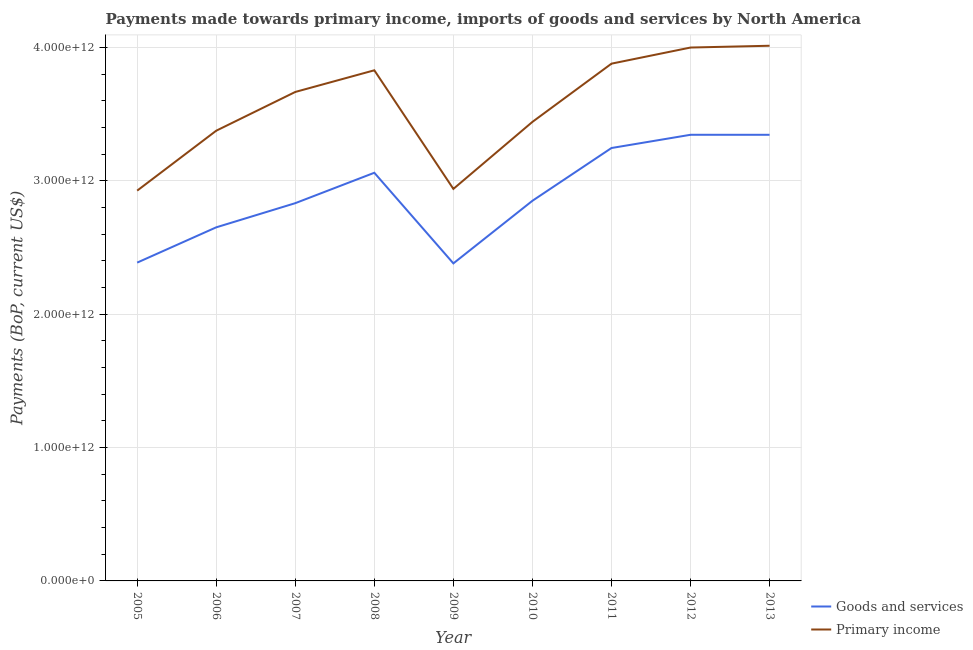Does the line corresponding to payments made towards goods and services intersect with the line corresponding to payments made towards primary income?
Your answer should be compact. No. What is the payments made towards primary income in 2012?
Provide a short and direct response. 4.00e+12. Across all years, what is the maximum payments made towards primary income?
Offer a terse response. 4.01e+12. Across all years, what is the minimum payments made towards goods and services?
Offer a very short reply. 2.38e+12. In which year was the payments made towards primary income minimum?
Your answer should be very brief. 2005. What is the total payments made towards goods and services in the graph?
Offer a terse response. 2.61e+13. What is the difference between the payments made towards goods and services in 2005 and that in 2012?
Make the answer very short. -9.58e+11. What is the difference between the payments made towards goods and services in 2006 and the payments made towards primary income in 2008?
Offer a terse response. -1.18e+12. What is the average payments made towards goods and services per year?
Offer a very short reply. 2.90e+12. In the year 2011, what is the difference between the payments made towards primary income and payments made towards goods and services?
Your answer should be very brief. 6.32e+11. What is the ratio of the payments made towards primary income in 2010 to that in 2012?
Provide a short and direct response. 0.86. Is the payments made towards primary income in 2006 less than that in 2008?
Offer a terse response. Yes. Is the difference between the payments made towards goods and services in 2008 and 2010 greater than the difference between the payments made towards primary income in 2008 and 2010?
Keep it short and to the point. No. What is the difference between the highest and the second highest payments made towards goods and services?
Give a very brief answer. 1.09e+08. What is the difference between the highest and the lowest payments made towards goods and services?
Give a very brief answer. 9.64e+11. Is the payments made towards primary income strictly greater than the payments made towards goods and services over the years?
Keep it short and to the point. Yes. What is the difference between two consecutive major ticks on the Y-axis?
Make the answer very short. 1.00e+12. Are the values on the major ticks of Y-axis written in scientific E-notation?
Ensure brevity in your answer.  Yes. Does the graph contain any zero values?
Give a very brief answer. No. How many legend labels are there?
Give a very brief answer. 2. How are the legend labels stacked?
Provide a succinct answer. Vertical. What is the title of the graph?
Your answer should be very brief. Payments made towards primary income, imports of goods and services by North America. What is the label or title of the Y-axis?
Your response must be concise. Payments (BoP, current US$). What is the Payments (BoP, current US$) of Goods and services in 2005?
Your answer should be very brief. 2.39e+12. What is the Payments (BoP, current US$) in Primary income in 2005?
Your response must be concise. 2.93e+12. What is the Payments (BoP, current US$) of Goods and services in 2006?
Make the answer very short. 2.65e+12. What is the Payments (BoP, current US$) in Primary income in 2006?
Ensure brevity in your answer.  3.38e+12. What is the Payments (BoP, current US$) of Goods and services in 2007?
Provide a short and direct response. 2.83e+12. What is the Payments (BoP, current US$) of Primary income in 2007?
Your response must be concise. 3.67e+12. What is the Payments (BoP, current US$) in Goods and services in 2008?
Provide a short and direct response. 3.06e+12. What is the Payments (BoP, current US$) of Primary income in 2008?
Make the answer very short. 3.83e+12. What is the Payments (BoP, current US$) in Goods and services in 2009?
Make the answer very short. 2.38e+12. What is the Payments (BoP, current US$) of Primary income in 2009?
Offer a terse response. 2.94e+12. What is the Payments (BoP, current US$) of Goods and services in 2010?
Your answer should be very brief. 2.85e+12. What is the Payments (BoP, current US$) in Primary income in 2010?
Your response must be concise. 3.44e+12. What is the Payments (BoP, current US$) in Goods and services in 2011?
Ensure brevity in your answer.  3.25e+12. What is the Payments (BoP, current US$) in Primary income in 2011?
Offer a terse response. 3.88e+12. What is the Payments (BoP, current US$) in Goods and services in 2012?
Keep it short and to the point. 3.34e+12. What is the Payments (BoP, current US$) in Primary income in 2012?
Provide a short and direct response. 4.00e+12. What is the Payments (BoP, current US$) in Goods and services in 2013?
Keep it short and to the point. 3.34e+12. What is the Payments (BoP, current US$) of Primary income in 2013?
Provide a short and direct response. 4.01e+12. Across all years, what is the maximum Payments (BoP, current US$) in Goods and services?
Provide a short and direct response. 3.34e+12. Across all years, what is the maximum Payments (BoP, current US$) of Primary income?
Provide a short and direct response. 4.01e+12. Across all years, what is the minimum Payments (BoP, current US$) of Goods and services?
Provide a short and direct response. 2.38e+12. Across all years, what is the minimum Payments (BoP, current US$) in Primary income?
Provide a short and direct response. 2.93e+12. What is the total Payments (BoP, current US$) of Goods and services in the graph?
Your answer should be very brief. 2.61e+13. What is the total Payments (BoP, current US$) of Primary income in the graph?
Make the answer very short. 3.21e+13. What is the difference between the Payments (BoP, current US$) of Goods and services in 2005 and that in 2006?
Give a very brief answer. -2.65e+11. What is the difference between the Payments (BoP, current US$) in Primary income in 2005 and that in 2006?
Make the answer very short. -4.49e+11. What is the difference between the Payments (BoP, current US$) of Goods and services in 2005 and that in 2007?
Your response must be concise. -4.46e+11. What is the difference between the Payments (BoP, current US$) of Primary income in 2005 and that in 2007?
Your answer should be very brief. -7.40e+11. What is the difference between the Payments (BoP, current US$) of Goods and services in 2005 and that in 2008?
Provide a succinct answer. -6.74e+11. What is the difference between the Payments (BoP, current US$) of Primary income in 2005 and that in 2008?
Offer a terse response. -9.02e+11. What is the difference between the Payments (BoP, current US$) of Goods and services in 2005 and that in 2009?
Keep it short and to the point. 5.74e+09. What is the difference between the Payments (BoP, current US$) of Primary income in 2005 and that in 2009?
Your answer should be very brief. -1.30e+1. What is the difference between the Payments (BoP, current US$) in Goods and services in 2005 and that in 2010?
Your answer should be very brief. -4.64e+11. What is the difference between the Payments (BoP, current US$) of Primary income in 2005 and that in 2010?
Offer a terse response. -5.15e+11. What is the difference between the Payments (BoP, current US$) of Goods and services in 2005 and that in 2011?
Provide a succinct answer. -8.59e+11. What is the difference between the Payments (BoP, current US$) in Primary income in 2005 and that in 2011?
Provide a succinct answer. -9.52e+11. What is the difference between the Payments (BoP, current US$) in Goods and services in 2005 and that in 2012?
Provide a succinct answer. -9.58e+11. What is the difference between the Payments (BoP, current US$) in Primary income in 2005 and that in 2012?
Make the answer very short. -1.07e+12. What is the difference between the Payments (BoP, current US$) of Goods and services in 2005 and that in 2013?
Ensure brevity in your answer.  -9.58e+11. What is the difference between the Payments (BoP, current US$) in Primary income in 2005 and that in 2013?
Ensure brevity in your answer.  -1.09e+12. What is the difference between the Payments (BoP, current US$) in Goods and services in 2006 and that in 2007?
Your response must be concise. -1.81e+11. What is the difference between the Payments (BoP, current US$) in Primary income in 2006 and that in 2007?
Ensure brevity in your answer.  -2.91e+11. What is the difference between the Payments (BoP, current US$) in Goods and services in 2006 and that in 2008?
Your answer should be compact. -4.09e+11. What is the difference between the Payments (BoP, current US$) in Primary income in 2006 and that in 2008?
Offer a terse response. -4.53e+11. What is the difference between the Payments (BoP, current US$) of Goods and services in 2006 and that in 2009?
Make the answer very short. 2.70e+11. What is the difference between the Payments (BoP, current US$) in Primary income in 2006 and that in 2009?
Keep it short and to the point. 4.36e+11. What is the difference between the Payments (BoP, current US$) of Goods and services in 2006 and that in 2010?
Keep it short and to the point. -1.99e+11. What is the difference between the Payments (BoP, current US$) in Primary income in 2006 and that in 2010?
Your response must be concise. -6.61e+1. What is the difference between the Payments (BoP, current US$) of Goods and services in 2006 and that in 2011?
Ensure brevity in your answer.  -5.95e+11. What is the difference between the Payments (BoP, current US$) of Primary income in 2006 and that in 2011?
Make the answer very short. -5.03e+11. What is the difference between the Payments (BoP, current US$) in Goods and services in 2006 and that in 2012?
Your response must be concise. -6.94e+11. What is the difference between the Payments (BoP, current US$) in Primary income in 2006 and that in 2012?
Ensure brevity in your answer.  -6.24e+11. What is the difference between the Payments (BoP, current US$) in Goods and services in 2006 and that in 2013?
Your answer should be compact. -6.94e+11. What is the difference between the Payments (BoP, current US$) of Primary income in 2006 and that in 2013?
Your answer should be compact. -6.37e+11. What is the difference between the Payments (BoP, current US$) in Goods and services in 2007 and that in 2008?
Give a very brief answer. -2.28e+11. What is the difference between the Payments (BoP, current US$) of Primary income in 2007 and that in 2008?
Provide a short and direct response. -1.62e+11. What is the difference between the Payments (BoP, current US$) of Goods and services in 2007 and that in 2009?
Your response must be concise. 4.51e+11. What is the difference between the Payments (BoP, current US$) in Primary income in 2007 and that in 2009?
Provide a short and direct response. 7.27e+11. What is the difference between the Payments (BoP, current US$) in Goods and services in 2007 and that in 2010?
Provide a short and direct response. -1.79e+1. What is the difference between the Payments (BoP, current US$) in Primary income in 2007 and that in 2010?
Offer a very short reply. 2.24e+11. What is the difference between the Payments (BoP, current US$) of Goods and services in 2007 and that in 2011?
Ensure brevity in your answer.  -4.14e+11. What is the difference between the Payments (BoP, current US$) of Primary income in 2007 and that in 2011?
Provide a succinct answer. -2.12e+11. What is the difference between the Payments (BoP, current US$) of Goods and services in 2007 and that in 2012?
Give a very brief answer. -5.13e+11. What is the difference between the Payments (BoP, current US$) in Primary income in 2007 and that in 2012?
Make the answer very short. -3.33e+11. What is the difference between the Payments (BoP, current US$) in Goods and services in 2007 and that in 2013?
Give a very brief answer. -5.13e+11. What is the difference between the Payments (BoP, current US$) in Primary income in 2007 and that in 2013?
Your response must be concise. -3.46e+11. What is the difference between the Payments (BoP, current US$) of Goods and services in 2008 and that in 2009?
Offer a very short reply. 6.79e+11. What is the difference between the Payments (BoP, current US$) of Primary income in 2008 and that in 2009?
Offer a very short reply. 8.89e+11. What is the difference between the Payments (BoP, current US$) of Goods and services in 2008 and that in 2010?
Your answer should be very brief. 2.10e+11. What is the difference between the Payments (BoP, current US$) of Primary income in 2008 and that in 2010?
Make the answer very short. 3.87e+11. What is the difference between the Payments (BoP, current US$) in Goods and services in 2008 and that in 2011?
Provide a short and direct response. -1.86e+11. What is the difference between the Payments (BoP, current US$) of Primary income in 2008 and that in 2011?
Give a very brief answer. -4.97e+1. What is the difference between the Payments (BoP, current US$) of Goods and services in 2008 and that in 2012?
Your response must be concise. -2.85e+11. What is the difference between the Payments (BoP, current US$) in Primary income in 2008 and that in 2012?
Your answer should be very brief. -1.71e+11. What is the difference between the Payments (BoP, current US$) of Goods and services in 2008 and that in 2013?
Your answer should be compact. -2.85e+11. What is the difference between the Payments (BoP, current US$) in Primary income in 2008 and that in 2013?
Your response must be concise. -1.84e+11. What is the difference between the Payments (BoP, current US$) in Goods and services in 2009 and that in 2010?
Keep it short and to the point. -4.69e+11. What is the difference between the Payments (BoP, current US$) of Primary income in 2009 and that in 2010?
Your response must be concise. -5.02e+11. What is the difference between the Payments (BoP, current US$) in Goods and services in 2009 and that in 2011?
Your answer should be compact. -8.65e+11. What is the difference between the Payments (BoP, current US$) in Primary income in 2009 and that in 2011?
Provide a succinct answer. -9.39e+11. What is the difference between the Payments (BoP, current US$) in Goods and services in 2009 and that in 2012?
Your answer should be very brief. -9.64e+11. What is the difference between the Payments (BoP, current US$) of Primary income in 2009 and that in 2012?
Provide a short and direct response. -1.06e+12. What is the difference between the Payments (BoP, current US$) of Goods and services in 2009 and that in 2013?
Ensure brevity in your answer.  -9.64e+11. What is the difference between the Payments (BoP, current US$) of Primary income in 2009 and that in 2013?
Your answer should be compact. -1.07e+12. What is the difference between the Payments (BoP, current US$) in Goods and services in 2010 and that in 2011?
Provide a short and direct response. -3.96e+11. What is the difference between the Payments (BoP, current US$) of Primary income in 2010 and that in 2011?
Your response must be concise. -4.37e+11. What is the difference between the Payments (BoP, current US$) of Goods and services in 2010 and that in 2012?
Offer a very short reply. -4.95e+11. What is the difference between the Payments (BoP, current US$) in Primary income in 2010 and that in 2012?
Provide a short and direct response. -5.57e+11. What is the difference between the Payments (BoP, current US$) of Goods and services in 2010 and that in 2013?
Offer a very short reply. -4.95e+11. What is the difference between the Payments (BoP, current US$) in Primary income in 2010 and that in 2013?
Your response must be concise. -5.71e+11. What is the difference between the Payments (BoP, current US$) in Goods and services in 2011 and that in 2012?
Keep it short and to the point. -9.92e+1. What is the difference between the Payments (BoP, current US$) in Primary income in 2011 and that in 2012?
Make the answer very short. -1.21e+11. What is the difference between the Payments (BoP, current US$) of Goods and services in 2011 and that in 2013?
Your answer should be very brief. -9.91e+1. What is the difference between the Payments (BoP, current US$) of Primary income in 2011 and that in 2013?
Your answer should be very brief. -1.34e+11. What is the difference between the Payments (BoP, current US$) of Goods and services in 2012 and that in 2013?
Give a very brief answer. 1.09e+08. What is the difference between the Payments (BoP, current US$) in Primary income in 2012 and that in 2013?
Offer a very short reply. -1.33e+1. What is the difference between the Payments (BoP, current US$) in Goods and services in 2005 and the Payments (BoP, current US$) in Primary income in 2006?
Your answer should be very brief. -9.89e+11. What is the difference between the Payments (BoP, current US$) of Goods and services in 2005 and the Payments (BoP, current US$) of Primary income in 2007?
Your response must be concise. -1.28e+12. What is the difference between the Payments (BoP, current US$) in Goods and services in 2005 and the Payments (BoP, current US$) in Primary income in 2008?
Ensure brevity in your answer.  -1.44e+12. What is the difference between the Payments (BoP, current US$) in Goods and services in 2005 and the Payments (BoP, current US$) in Primary income in 2009?
Offer a very short reply. -5.53e+11. What is the difference between the Payments (BoP, current US$) in Goods and services in 2005 and the Payments (BoP, current US$) in Primary income in 2010?
Provide a short and direct response. -1.06e+12. What is the difference between the Payments (BoP, current US$) in Goods and services in 2005 and the Payments (BoP, current US$) in Primary income in 2011?
Provide a short and direct response. -1.49e+12. What is the difference between the Payments (BoP, current US$) of Goods and services in 2005 and the Payments (BoP, current US$) of Primary income in 2012?
Keep it short and to the point. -1.61e+12. What is the difference between the Payments (BoP, current US$) of Goods and services in 2005 and the Payments (BoP, current US$) of Primary income in 2013?
Your answer should be compact. -1.63e+12. What is the difference between the Payments (BoP, current US$) in Goods and services in 2006 and the Payments (BoP, current US$) in Primary income in 2007?
Provide a succinct answer. -1.02e+12. What is the difference between the Payments (BoP, current US$) of Goods and services in 2006 and the Payments (BoP, current US$) of Primary income in 2008?
Ensure brevity in your answer.  -1.18e+12. What is the difference between the Payments (BoP, current US$) in Goods and services in 2006 and the Payments (BoP, current US$) in Primary income in 2009?
Provide a succinct answer. -2.88e+11. What is the difference between the Payments (BoP, current US$) in Goods and services in 2006 and the Payments (BoP, current US$) in Primary income in 2010?
Provide a succinct answer. -7.91e+11. What is the difference between the Payments (BoP, current US$) of Goods and services in 2006 and the Payments (BoP, current US$) of Primary income in 2011?
Give a very brief answer. -1.23e+12. What is the difference between the Payments (BoP, current US$) of Goods and services in 2006 and the Payments (BoP, current US$) of Primary income in 2012?
Offer a very short reply. -1.35e+12. What is the difference between the Payments (BoP, current US$) in Goods and services in 2006 and the Payments (BoP, current US$) in Primary income in 2013?
Your answer should be very brief. -1.36e+12. What is the difference between the Payments (BoP, current US$) of Goods and services in 2007 and the Payments (BoP, current US$) of Primary income in 2008?
Offer a terse response. -9.96e+11. What is the difference between the Payments (BoP, current US$) in Goods and services in 2007 and the Payments (BoP, current US$) in Primary income in 2009?
Give a very brief answer. -1.07e+11. What is the difference between the Payments (BoP, current US$) in Goods and services in 2007 and the Payments (BoP, current US$) in Primary income in 2010?
Your response must be concise. -6.09e+11. What is the difference between the Payments (BoP, current US$) of Goods and services in 2007 and the Payments (BoP, current US$) of Primary income in 2011?
Your answer should be compact. -1.05e+12. What is the difference between the Payments (BoP, current US$) of Goods and services in 2007 and the Payments (BoP, current US$) of Primary income in 2012?
Keep it short and to the point. -1.17e+12. What is the difference between the Payments (BoP, current US$) of Goods and services in 2007 and the Payments (BoP, current US$) of Primary income in 2013?
Offer a terse response. -1.18e+12. What is the difference between the Payments (BoP, current US$) in Goods and services in 2008 and the Payments (BoP, current US$) in Primary income in 2009?
Keep it short and to the point. 1.21e+11. What is the difference between the Payments (BoP, current US$) in Goods and services in 2008 and the Payments (BoP, current US$) in Primary income in 2010?
Give a very brief answer. -3.81e+11. What is the difference between the Payments (BoP, current US$) in Goods and services in 2008 and the Payments (BoP, current US$) in Primary income in 2011?
Your answer should be very brief. -8.18e+11. What is the difference between the Payments (BoP, current US$) in Goods and services in 2008 and the Payments (BoP, current US$) in Primary income in 2012?
Provide a succinct answer. -9.39e+11. What is the difference between the Payments (BoP, current US$) of Goods and services in 2008 and the Payments (BoP, current US$) of Primary income in 2013?
Ensure brevity in your answer.  -9.52e+11. What is the difference between the Payments (BoP, current US$) in Goods and services in 2009 and the Payments (BoP, current US$) in Primary income in 2010?
Your response must be concise. -1.06e+12. What is the difference between the Payments (BoP, current US$) in Goods and services in 2009 and the Payments (BoP, current US$) in Primary income in 2011?
Offer a very short reply. -1.50e+12. What is the difference between the Payments (BoP, current US$) of Goods and services in 2009 and the Payments (BoP, current US$) of Primary income in 2012?
Your answer should be compact. -1.62e+12. What is the difference between the Payments (BoP, current US$) of Goods and services in 2009 and the Payments (BoP, current US$) of Primary income in 2013?
Provide a succinct answer. -1.63e+12. What is the difference between the Payments (BoP, current US$) in Goods and services in 2010 and the Payments (BoP, current US$) in Primary income in 2011?
Provide a succinct answer. -1.03e+12. What is the difference between the Payments (BoP, current US$) of Goods and services in 2010 and the Payments (BoP, current US$) of Primary income in 2012?
Keep it short and to the point. -1.15e+12. What is the difference between the Payments (BoP, current US$) of Goods and services in 2010 and the Payments (BoP, current US$) of Primary income in 2013?
Keep it short and to the point. -1.16e+12. What is the difference between the Payments (BoP, current US$) of Goods and services in 2011 and the Payments (BoP, current US$) of Primary income in 2012?
Provide a short and direct response. -7.53e+11. What is the difference between the Payments (BoP, current US$) in Goods and services in 2011 and the Payments (BoP, current US$) in Primary income in 2013?
Keep it short and to the point. -7.67e+11. What is the difference between the Payments (BoP, current US$) of Goods and services in 2012 and the Payments (BoP, current US$) of Primary income in 2013?
Your response must be concise. -6.67e+11. What is the average Payments (BoP, current US$) of Goods and services per year?
Your response must be concise. 2.90e+12. What is the average Payments (BoP, current US$) in Primary income per year?
Ensure brevity in your answer.  3.56e+12. In the year 2005, what is the difference between the Payments (BoP, current US$) of Goods and services and Payments (BoP, current US$) of Primary income?
Ensure brevity in your answer.  -5.40e+11. In the year 2006, what is the difference between the Payments (BoP, current US$) in Goods and services and Payments (BoP, current US$) in Primary income?
Offer a terse response. -7.24e+11. In the year 2007, what is the difference between the Payments (BoP, current US$) in Goods and services and Payments (BoP, current US$) in Primary income?
Your answer should be compact. -8.34e+11. In the year 2008, what is the difference between the Payments (BoP, current US$) of Goods and services and Payments (BoP, current US$) of Primary income?
Your answer should be very brief. -7.68e+11. In the year 2009, what is the difference between the Payments (BoP, current US$) in Goods and services and Payments (BoP, current US$) in Primary income?
Offer a terse response. -5.58e+11. In the year 2010, what is the difference between the Payments (BoP, current US$) of Goods and services and Payments (BoP, current US$) of Primary income?
Provide a succinct answer. -5.91e+11. In the year 2011, what is the difference between the Payments (BoP, current US$) of Goods and services and Payments (BoP, current US$) of Primary income?
Give a very brief answer. -6.32e+11. In the year 2012, what is the difference between the Payments (BoP, current US$) in Goods and services and Payments (BoP, current US$) in Primary income?
Provide a short and direct response. -6.54e+11. In the year 2013, what is the difference between the Payments (BoP, current US$) in Goods and services and Payments (BoP, current US$) in Primary income?
Provide a short and direct response. -6.68e+11. What is the ratio of the Payments (BoP, current US$) in Goods and services in 2005 to that in 2006?
Your answer should be compact. 0.9. What is the ratio of the Payments (BoP, current US$) in Primary income in 2005 to that in 2006?
Your answer should be very brief. 0.87. What is the ratio of the Payments (BoP, current US$) of Goods and services in 2005 to that in 2007?
Provide a short and direct response. 0.84. What is the ratio of the Payments (BoP, current US$) of Primary income in 2005 to that in 2007?
Offer a very short reply. 0.8. What is the ratio of the Payments (BoP, current US$) of Goods and services in 2005 to that in 2008?
Your answer should be compact. 0.78. What is the ratio of the Payments (BoP, current US$) of Primary income in 2005 to that in 2008?
Your answer should be very brief. 0.76. What is the ratio of the Payments (BoP, current US$) of Primary income in 2005 to that in 2009?
Ensure brevity in your answer.  1. What is the ratio of the Payments (BoP, current US$) in Goods and services in 2005 to that in 2010?
Your response must be concise. 0.84. What is the ratio of the Payments (BoP, current US$) in Primary income in 2005 to that in 2010?
Provide a short and direct response. 0.85. What is the ratio of the Payments (BoP, current US$) in Goods and services in 2005 to that in 2011?
Provide a succinct answer. 0.74. What is the ratio of the Payments (BoP, current US$) of Primary income in 2005 to that in 2011?
Your answer should be compact. 0.75. What is the ratio of the Payments (BoP, current US$) of Goods and services in 2005 to that in 2012?
Your response must be concise. 0.71. What is the ratio of the Payments (BoP, current US$) of Primary income in 2005 to that in 2012?
Provide a succinct answer. 0.73. What is the ratio of the Payments (BoP, current US$) of Goods and services in 2005 to that in 2013?
Provide a succinct answer. 0.71. What is the ratio of the Payments (BoP, current US$) of Primary income in 2005 to that in 2013?
Offer a very short reply. 0.73. What is the ratio of the Payments (BoP, current US$) of Goods and services in 2006 to that in 2007?
Your response must be concise. 0.94. What is the ratio of the Payments (BoP, current US$) of Primary income in 2006 to that in 2007?
Your response must be concise. 0.92. What is the ratio of the Payments (BoP, current US$) in Goods and services in 2006 to that in 2008?
Offer a very short reply. 0.87. What is the ratio of the Payments (BoP, current US$) in Primary income in 2006 to that in 2008?
Give a very brief answer. 0.88. What is the ratio of the Payments (BoP, current US$) of Goods and services in 2006 to that in 2009?
Your response must be concise. 1.11. What is the ratio of the Payments (BoP, current US$) of Primary income in 2006 to that in 2009?
Ensure brevity in your answer.  1.15. What is the ratio of the Payments (BoP, current US$) of Goods and services in 2006 to that in 2010?
Your answer should be compact. 0.93. What is the ratio of the Payments (BoP, current US$) of Primary income in 2006 to that in 2010?
Your answer should be very brief. 0.98. What is the ratio of the Payments (BoP, current US$) in Goods and services in 2006 to that in 2011?
Give a very brief answer. 0.82. What is the ratio of the Payments (BoP, current US$) of Primary income in 2006 to that in 2011?
Make the answer very short. 0.87. What is the ratio of the Payments (BoP, current US$) of Goods and services in 2006 to that in 2012?
Your answer should be compact. 0.79. What is the ratio of the Payments (BoP, current US$) of Primary income in 2006 to that in 2012?
Offer a terse response. 0.84. What is the ratio of the Payments (BoP, current US$) of Goods and services in 2006 to that in 2013?
Keep it short and to the point. 0.79. What is the ratio of the Payments (BoP, current US$) of Primary income in 2006 to that in 2013?
Provide a succinct answer. 0.84. What is the ratio of the Payments (BoP, current US$) of Goods and services in 2007 to that in 2008?
Keep it short and to the point. 0.93. What is the ratio of the Payments (BoP, current US$) of Primary income in 2007 to that in 2008?
Your answer should be very brief. 0.96. What is the ratio of the Payments (BoP, current US$) of Goods and services in 2007 to that in 2009?
Provide a short and direct response. 1.19. What is the ratio of the Payments (BoP, current US$) of Primary income in 2007 to that in 2009?
Offer a very short reply. 1.25. What is the ratio of the Payments (BoP, current US$) of Primary income in 2007 to that in 2010?
Give a very brief answer. 1.07. What is the ratio of the Payments (BoP, current US$) in Goods and services in 2007 to that in 2011?
Offer a very short reply. 0.87. What is the ratio of the Payments (BoP, current US$) of Primary income in 2007 to that in 2011?
Offer a terse response. 0.95. What is the ratio of the Payments (BoP, current US$) of Goods and services in 2007 to that in 2012?
Your answer should be very brief. 0.85. What is the ratio of the Payments (BoP, current US$) of Goods and services in 2007 to that in 2013?
Offer a terse response. 0.85. What is the ratio of the Payments (BoP, current US$) of Primary income in 2007 to that in 2013?
Your answer should be very brief. 0.91. What is the ratio of the Payments (BoP, current US$) in Goods and services in 2008 to that in 2009?
Provide a succinct answer. 1.29. What is the ratio of the Payments (BoP, current US$) of Primary income in 2008 to that in 2009?
Offer a terse response. 1.3. What is the ratio of the Payments (BoP, current US$) of Goods and services in 2008 to that in 2010?
Your answer should be very brief. 1.07. What is the ratio of the Payments (BoP, current US$) of Primary income in 2008 to that in 2010?
Your response must be concise. 1.11. What is the ratio of the Payments (BoP, current US$) in Goods and services in 2008 to that in 2011?
Your response must be concise. 0.94. What is the ratio of the Payments (BoP, current US$) of Primary income in 2008 to that in 2011?
Make the answer very short. 0.99. What is the ratio of the Payments (BoP, current US$) of Goods and services in 2008 to that in 2012?
Your answer should be very brief. 0.91. What is the ratio of the Payments (BoP, current US$) of Primary income in 2008 to that in 2012?
Your answer should be compact. 0.96. What is the ratio of the Payments (BoP, current US$) of Goods and services in 2008 to that in 2013?
Offer a very short reply. 0.91. What is the ratio of the Payments (BoP, current US$) of Primary income in 2008 to that in 2013?
Provide a short and direct response. 0.95. What is the ratio of the Payments (BoP, current US$) in Goods and services in 2009 to that in 2010?
Ensure brevity in your answer.  0.84. What is the ratio of the Payments (BoP, current US$) in Primary income in 2009 to that in 2010?
Make the answer very short. 0.85. What is the ratio of the Payments (BoP, current US$) of Goods and services in 2009 to that in 2011?
Ensure brevity in your answer.  0.73. What is the ratio of the Payments (BoP, current US$) of Primary income in 2009 to that in 2011?
Your answer should be very brief. 0.76. What is the ratio of the Payments (BoP, current US$) in Goods and services in 2009 to that in 2012?
Offer a terse response. 0.71. What is the ratio of the Payments (BoP, current US$) in Primary income in 2009 to that in 2012?
Provide a succinct answer. 0.73. What is the ratio of the Payments (BoP, current US$) in Goods and services in 2009 to that in 2013?
Your answer should be compact. 0.71. What is the ratio of the Payments (BoP, current US$) in Primary income in 2009 to that in 2013?
Provide a short and direct response. 0.73. What is the ratio of the Payments (BoP, current US$) in Goods and services in 2010 to that in 2011?
Your answer should be very brief. 0.88. What is the ratio of the Payments (BoP, current US$) of Primary income in 2010 to that in 2011?
Offer a very short reply. 0.89. What is the ratio of the Payments (BoP, current US$) in Goods and services in 2010 to that in 2012?
Ensure brevity in your answer.  0.85. What is the ratio of the Payments (BoP, current US$) of Primary income in 2010 to that in 2012?
Your response must be concise. 0.86. What is the ratio of the Payments (BoP, current US$) in Goods and services in 2010 to that in 2013?
Keep it short and to the point. 0.85. What is the ratio of the Payments (BoP, current US$) of Primary income in 2010 to that in 2013?
Provide a succinct answer. 0.86. What is the ratio of the Payments (BoP, current US$) in Goods and services in 2011 to that in 2012?
Give a very brief answer. 0.97. What is the ratio of the Payments (BoP, current US$) in Primary income in 2011 to that in 2012?
Provide a short and direct response. 0.97. What is the ratio of the Payments (BoP, current US$) of Goods and services in 2011 to that in 2013?
Keep it short and to the point. 0.97. What is the ratio of the Payments (BoP, current US$) in Primary income in 2011 to that in 2013?
Give a very brief answer. 0.97. What is the ratio of the Payments (BoP, current US$) in Primary income in 2012 to that in 2013?
Your response must be concise. 1. What is the difference between the highest and the second highest Payments (BoP, current US$) of Goods and services?
Make the answer very short. 1.09e+08. What is the difference between the highest and the second highest Payments (BoP, current US$) of Primary income?
Your answer should be very brief. 1.33e+1. What is the difference between the highest and the lowest Payments (BoP, current US$) in Goods and services?
Provide a short and direct response. 9.64e+11. What is the difference between the highest and the lowest Payments (BoP, current US$) in Primary income?
Provide a succinct answer. 1.09e+12. 